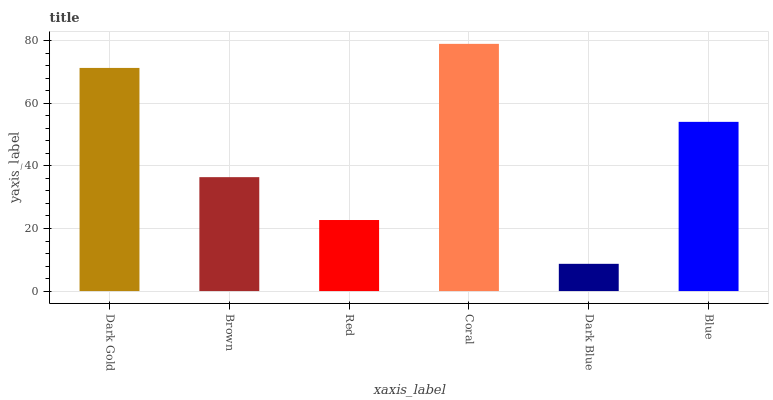Is Brown the minimum?
Answer yes or no. No. Is Brown the maximum?
Answer yes or no. No. Is Dark Gold greater than Brown?
Answer yes or no. Yes. Is Brown less than Dark Gold?
Answer yes or no. Yes. Is Brown greater than Dark Gold?
Answer yes or no. No. Is Dark Gold less than Brown?
Answer yes or no. No. Is Blue the high median?
Answer yes or no. Yes. Is Brown the low median?
Answer yes or no. Yes. Is Coral the high median?
Answer yes or no. No. Is Dark Gold the low median?
Answer yes or no. No. 